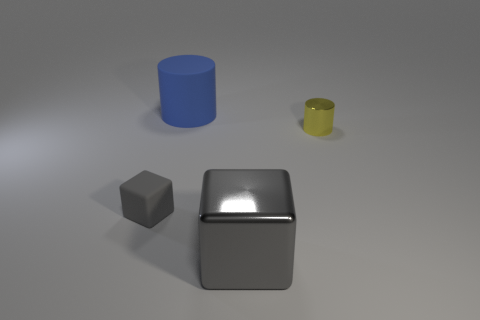Add 1 big blue rubber things. How many objects exist? 5 Subtract all gray shiny blocks. Subtract all big gray blocks. How many objects are left? 2 Add 2 rubber cylinders. How many rubber cylinders are left? 3 Add 4 red metal balls. How many red metal balls exist? 4 Subtract 0 red cylinders. How many objects are left? 4 